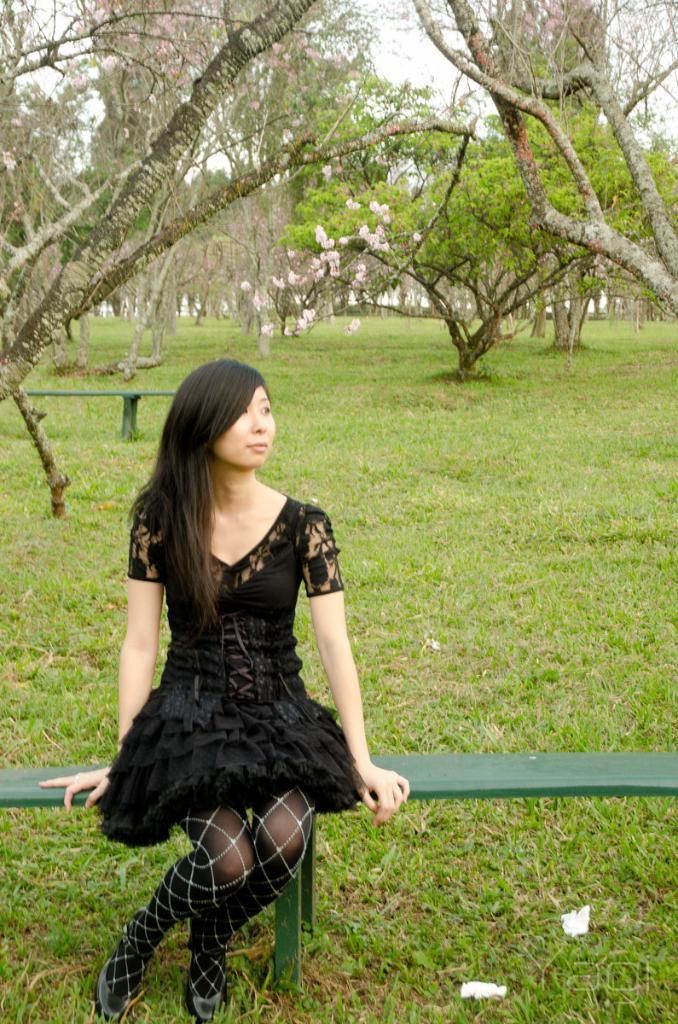In one or two sentences, can you explain what this image depicts? In this picture I can see there is a woman sitting on the bench and she is wearing a black dress and is looking at the right side, there is grass on the floor and there are few trees in the backdrop and the sky is clear. 